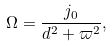Convert formula to latex. <formula><loc_0><loc_0><loc_500><loc_500>\Omega = \frac { j _ { 0 } } { d ^ { 2 } + \varpi ^ { 2 } } ,</formula> 